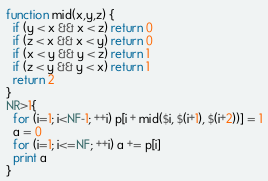Convert code to text. <code><loc_0><loc_0><loc_500><loc_500><_Awk_>function mid(x,y,z) {
  if (y < x && x < z) return 0
  if (z < x && x < y) return 0
  if (x < y && y < z) return 1
  if (z < y && y < x) return 1
  return 2
}
NR>1{
  for (i=1; i<NF-1; ++i) p[i + mid($i, $(i+1), $(i+2))] = 1
  a = 0
  for (i=1; i<=NF; ++i) a += p[i]
  print a
}
</code> 